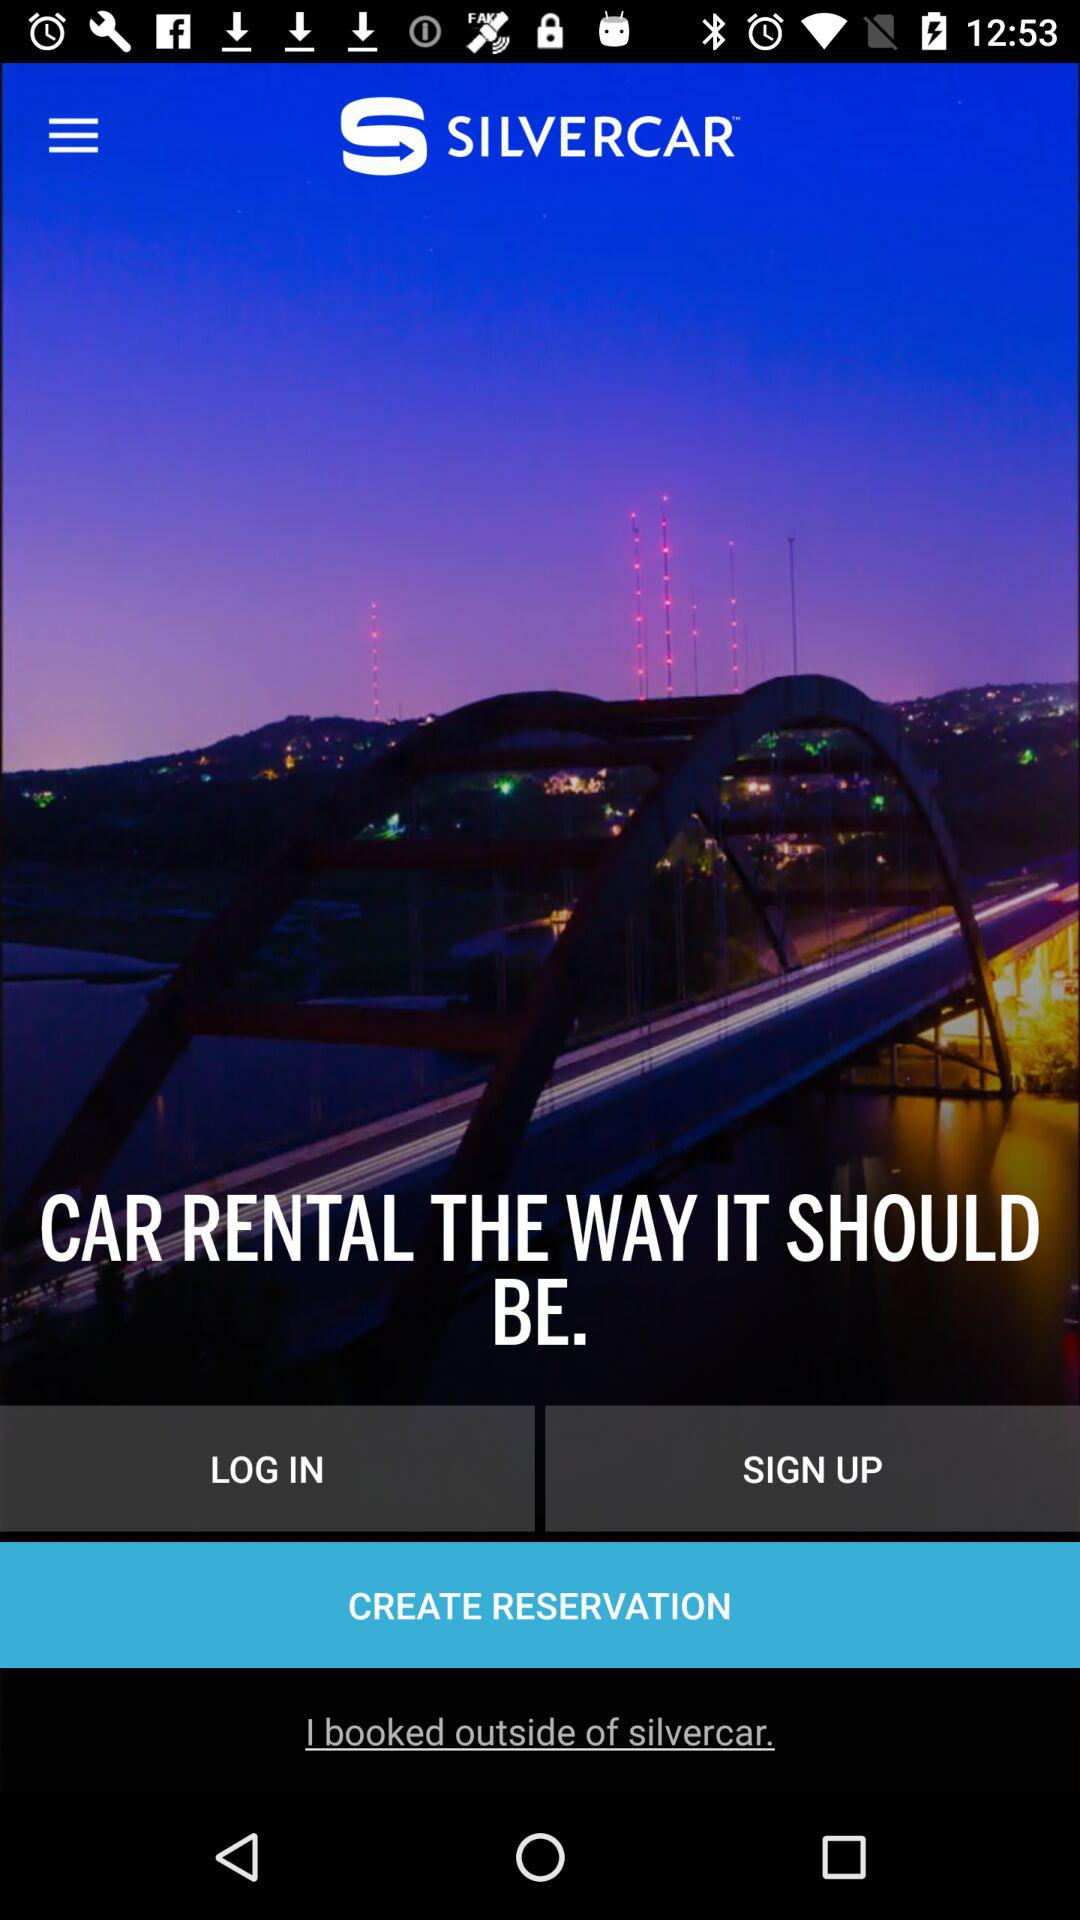What is the name of the application? The name of the application is "SILVERCAR". 